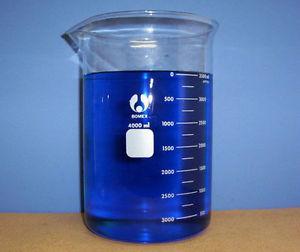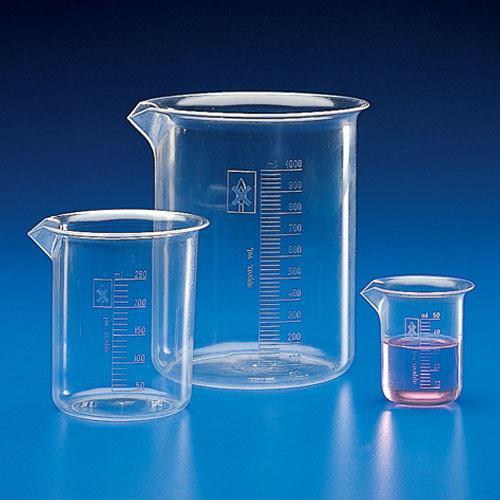The first image is the image on the left, the second image is the image on the right. Examine the images to the left and right. Is the description "There are at least four beaker." accurate? Answer yes or no. Yes. The first image is the image on the left, the second image is the image on the right. Given the left and right images, does the statement "Four or more beakers are visible." hold true? Answer yes or no. Yes. 